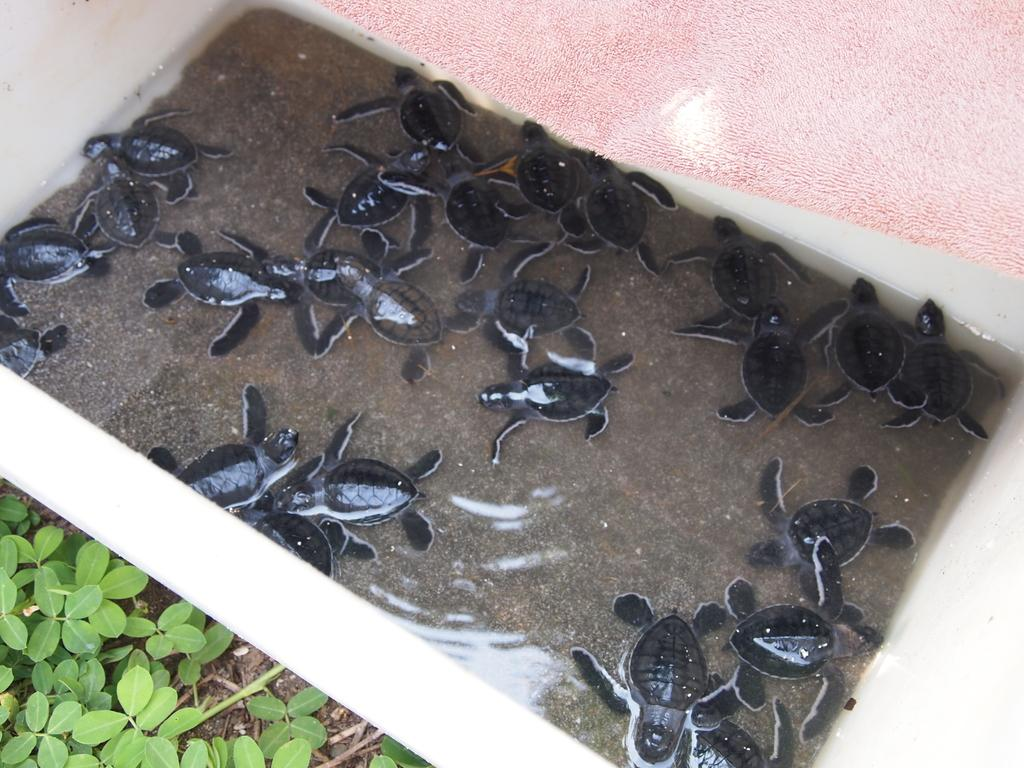What is the main element in the image? There is water in the image. What creatures can be seen in the water? There are turtles in the water. What is the color of the turtles? The turtles are black in color. What other colors are present in the image? There is a pink colored surface and green leaves of a plant in the image. What type of stamp can be seen on the turtles in the image? There are no stamps present on the turtles in the image. What kind of pets are visible in the image? The image does not show any pets; it features turtles in water. 